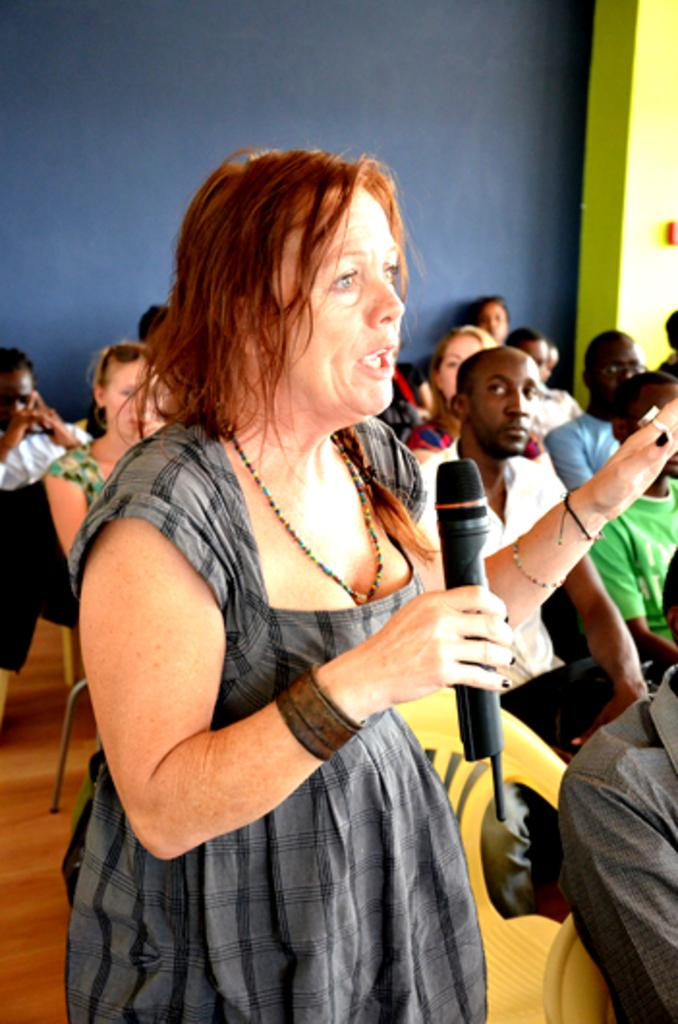Who is the main subject in the image? There is a woman in the image. What is the woman holding in the image? The woman is holding a microphone. What is the woman doing in the image? The woman is explaining something. Who are the other people in the image? There is a group of people sitting behind the woman. What can be seen in the background of the image? There is a wall visible in the image. What type of flesh can be seen on the wall in the image? There is no flesh visible on the wall in the image; it is a solid structure. 